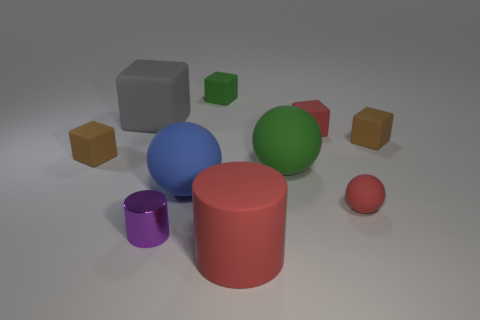Subtract all balls. How many objects are left? 7 Add 9 purple objects. How many purple objects exist? 10 Subtract 0 gray balls. How many objects are left? 10 Subtract all large cyan shiny cylinders. Subtract all green matte blocks. How many objects are left? 9 Add 9 big blue balls. How many big blue balls are left? 10 